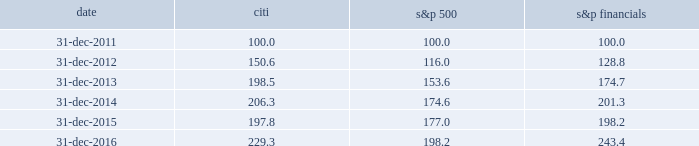Performance graph comparison of five-year cumulative total return the following graph and table compare the cumulative total return on citi 2019s common stock , which is listed on the nyse under the ticker symbol 201cc 201d and held by 77787 common stockholders of record as of january 31 , 2017 , with the cumulative total return of the s&p 500 index and the s&p financial index over the five-year period through december 31 , 2016 .
The graph and table assume that $ 100 was invested on december 31 , 2011 in citi 2019s common stock , the s&p 500 index and the s&p financial index , and that all dividends were reinvested .
Comparison of five-year cumulative total return for the years ended date citi s&p 500 financials .

In 2016 what was the ratio of the five-year cumulative total return for citi compared to s&p 500? 
Computations: ((229.3 - 100) / (198.2 - 100))
Answer: 1.3167. Performance graph comparison of five-year cumulative total return the following graph and table compare the cumulative total return on citi 2019s common stock , which is listed on the nyse under the ticker symbol 201cc 201d and held by 77787 common stockholders of record as of january 31 , 2017 , with the cumulative total return of the s&p 500 index and the s&p financial index over the five-year period through december 31 , 2016 .
The graph and table assume that $ 100 was invested on december 31 , 2011 in citi 2019s common stock , the s&p 500 index and the s&p financial index , and that all dividends were reinvested .
Comparison of five-year cumulative total return for the years ended date citi s&p 500 financials .

What was the percent of the growth for s&p financials cumulative total return from 2013 to 2014? 
Computations: (201.3 - 174.7)
Answer: 26.6. Performance graph comparison of five-year cumulative total return the following graph and table compare the cumulative total return on citi 2019s common stock , which is listed on the nyse under the ticker symbol 201cc 201d and held by 77787 common stockholders of record as of january 31 , 2017 , with the cumulative total return of the s&p 500 index and the s&p financial index over the five-year period through december 31 , 2016 .
The graph and table assume that $ 100 was invested on december 31 , 2011 in citi 2019s common stock , the s&p 500 index and the s&p financial index , and that all dividends were reinvested .
Comparison of five-year cumulative total return for the years ended date citi s&p 500 financials .

What was the difference in percentage cumulative total return between citi common stock and the s&p 500 for the five years ended december 31 , 2016? 
Computations: (((229.3 - 100) / 100) - ((198.2 - 100) / 100))
Answer: 0.311. 